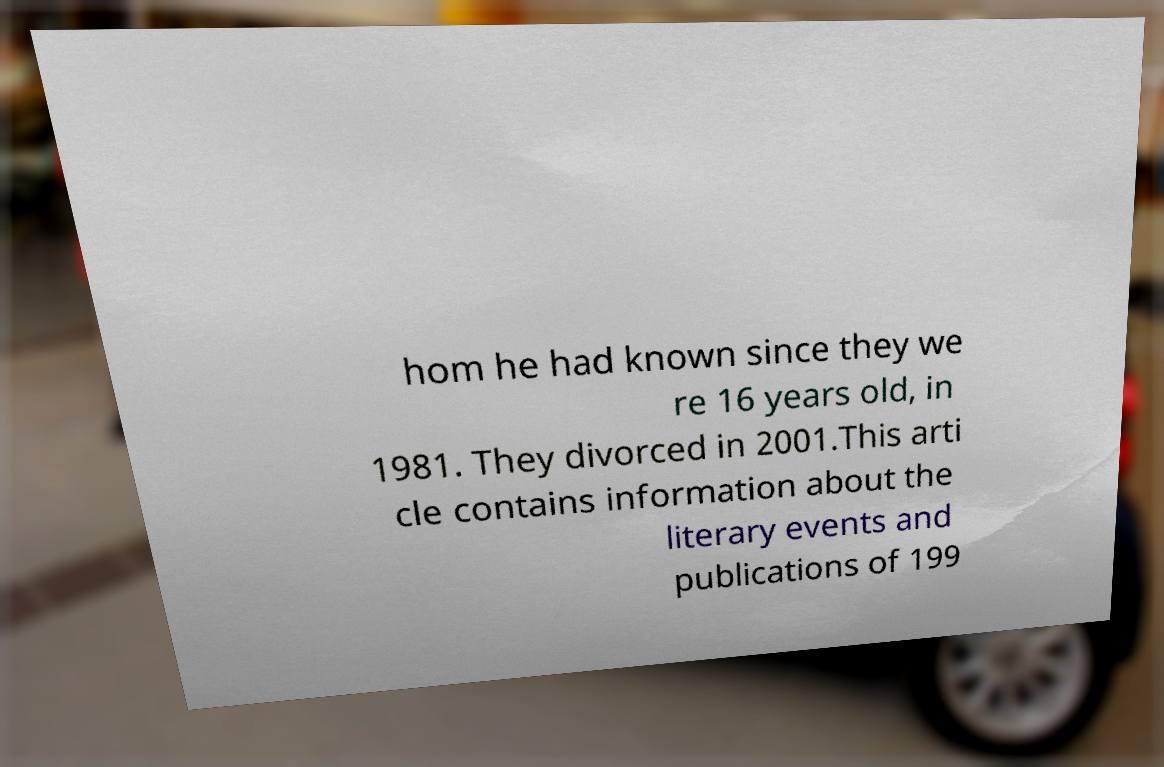Can you read and provide the text displayed in the image?This photo seems to have some interesting text. Can you extract and type it out for me? hom he had known since they we re 16 years old, in 1981. They divorced in 2001.This arti cle contains information about the literary events and publications of 199 